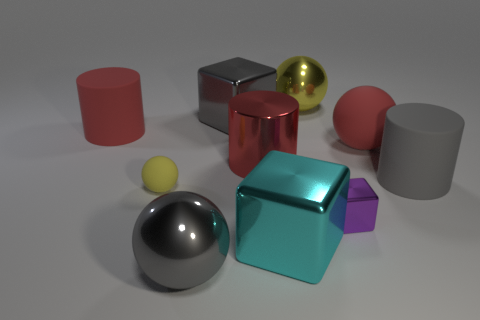Subtract all red balls. How many balls are left? 3 Subtract all big matte balls. How many balls are left? 3 Subtract all blue balls. Subtract all red cylinders. How many balls are left? 4 Subtract all cylinders. How many objects are left? 7 Subtract all big yellow things. Subtract all tiny metallic things. How many objects are left? 8 Add 1 large gray metal things. How many large gray metal things are left? 3 Add 6 red rubber things. How many red rubber things exist? 8 Subtract 1 gray blocks. How many objects are left? 9 